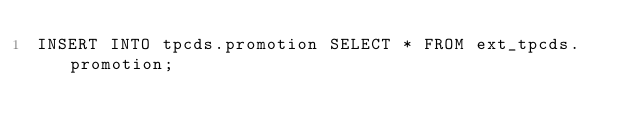Convert code to text. <code><loc_0><loc_0><loc_500><loc_500><_SQL_>INSERT INTO tpcds.promotion SELECT * FROM ext_tpcds.promotion;
</code> 